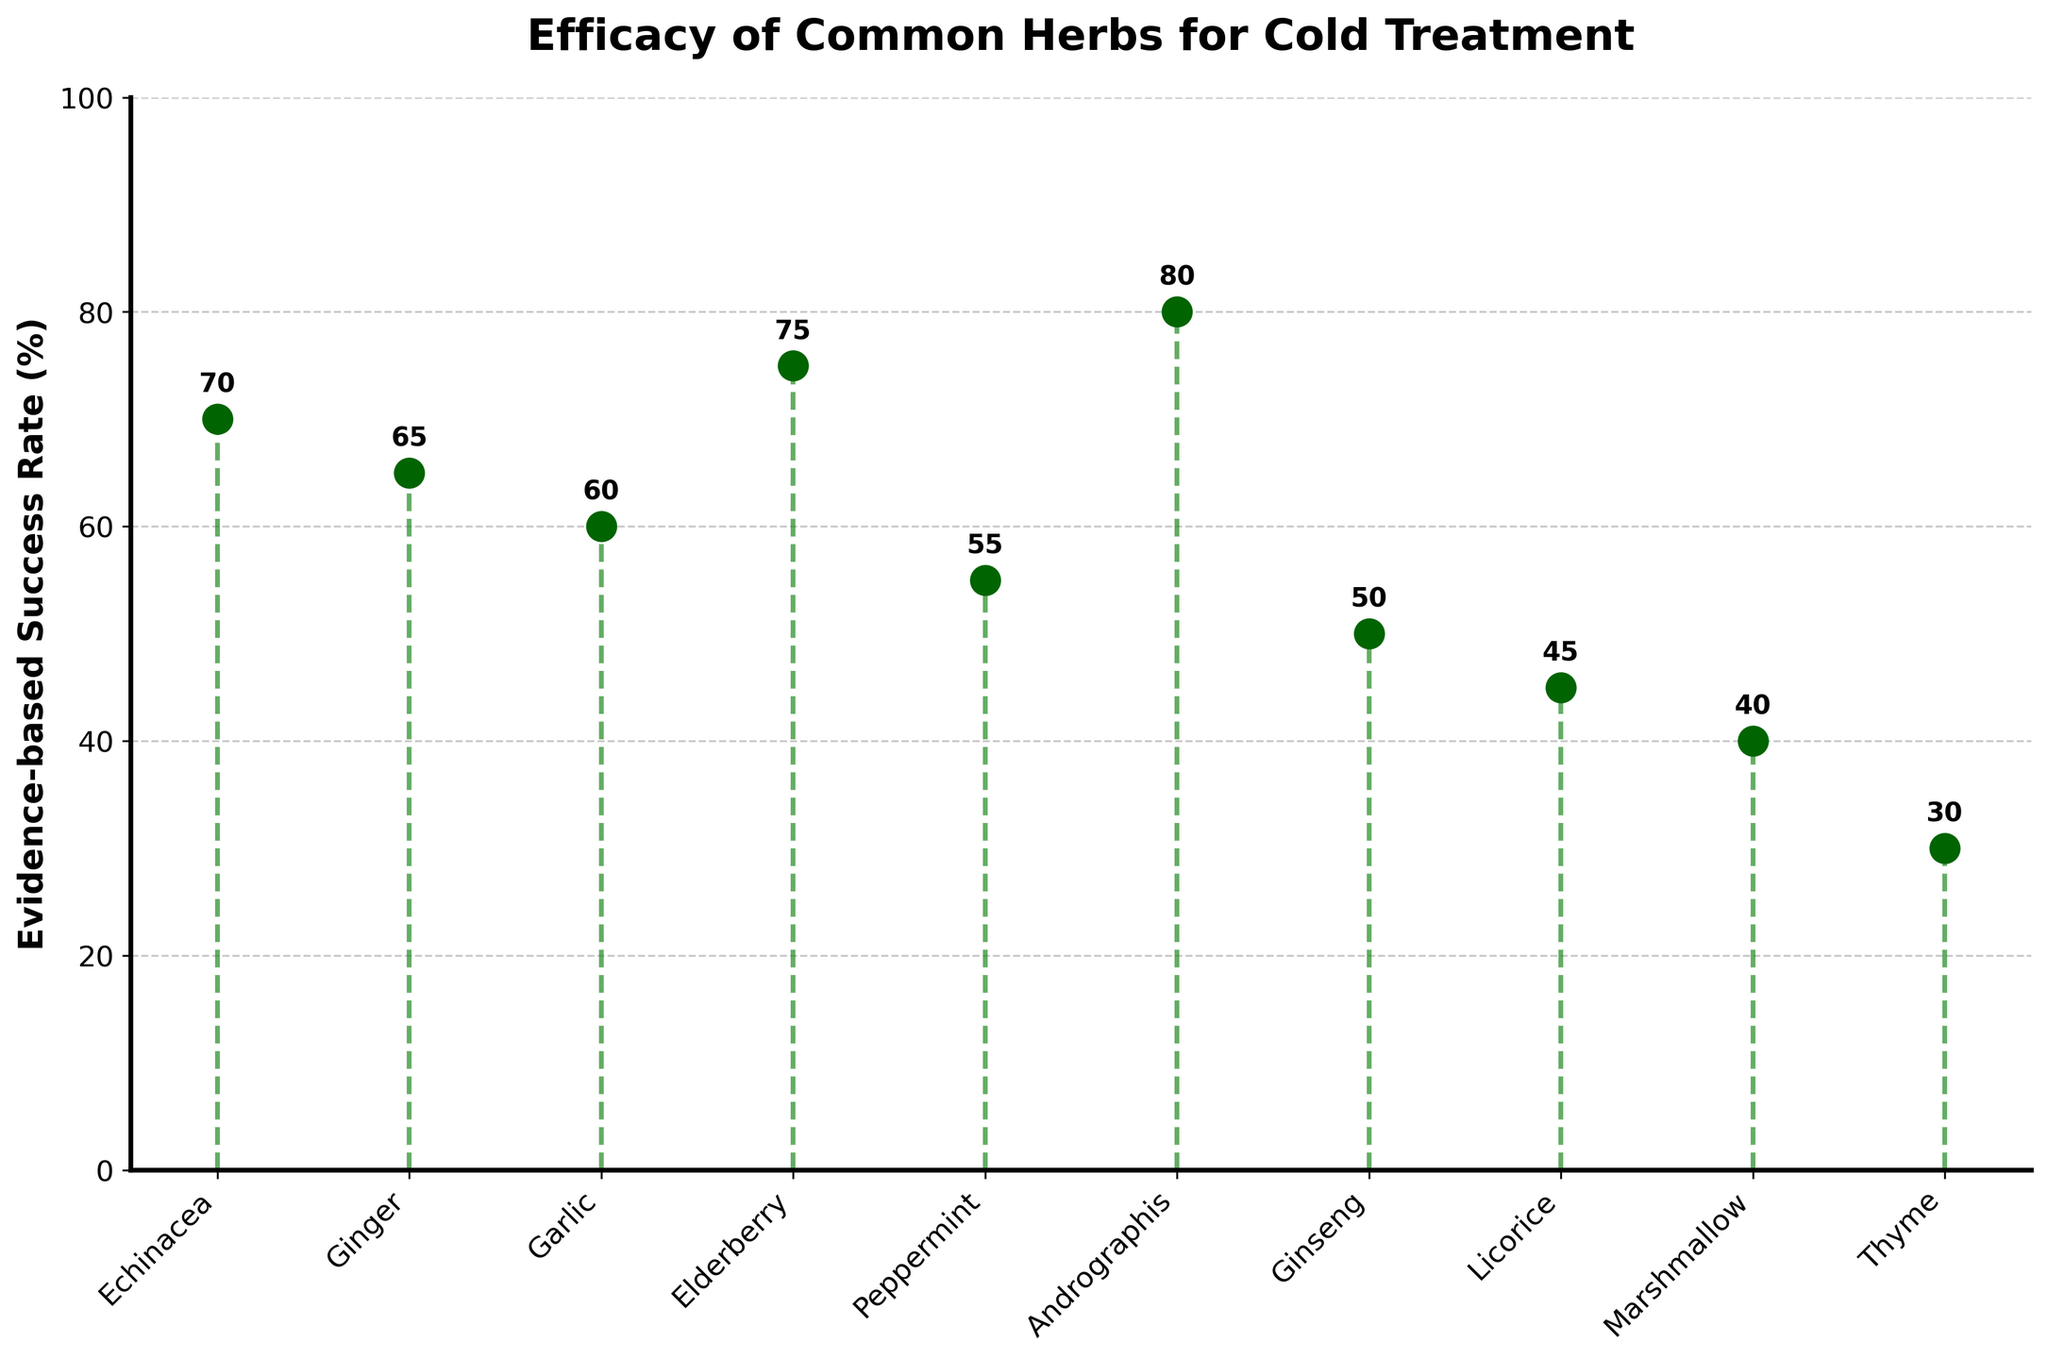What is the title of the stem plot? The title is displayed at the top of the stem plot, which reads "Efficacy of Common Herbs for Cold Treatment".
Answer: Efficacy of Common Herbs for Cold Treatment What is the evidence-based success rate of Elderberry? By examining the position of Elderberry on the x-axis, its success rate is marked at 75%.
Answer: 75% Which herb has the highest evidence-based success rate? By identifying the tallest stem, Andrographis has the highest success rate at 80%.
Answer: Andrographis What is the sum of the evidence-based success rates for Echinacea and Ginger? Echinacea has a success rate of 70%, and Ginger has a success rate of 65%. Adding them gives 70 + 65 = 135.
Answer: 135 What is the difference in evidence-based success rates between Ginseng and Garlic? Ginseng has a success rate of 50%, and Garlic has a success rate of 60%. Subtracting these gives 60 - 50 = 10.
Answer: 10 Which herb has a success rate less than 50% and is closest to that value? Identifying the stems below 50% and closest to it, Licorice has a success rate of 45%.
Answer: Licorice Which herb has the lowest evidence-based success rate? The shortest stem represents Thyme, with a 30% evidence-based success rate.
Answer: Thyme What is the average evidence-based success rate of all the herbs? Summing the success rates (70+65+60+75+55+80+50+45+40+30) gives 570. Dividing by the number of herbs (10) gives 570/10 = 57.
Answer: 57 How many herbs have a success rate higher than 60%? Counting the stems above 60%, there are Echinacea, Ginger, Elderberry, Andrographis. There are 4 herbs in total.
Answer: 4 What is the range of evidence-based success rates among the herbs? The highest success rate is 80% (Andrographis) and the lowest is 30% (Thyme). The range is 80 - 30 = 50.
Answer: 50 